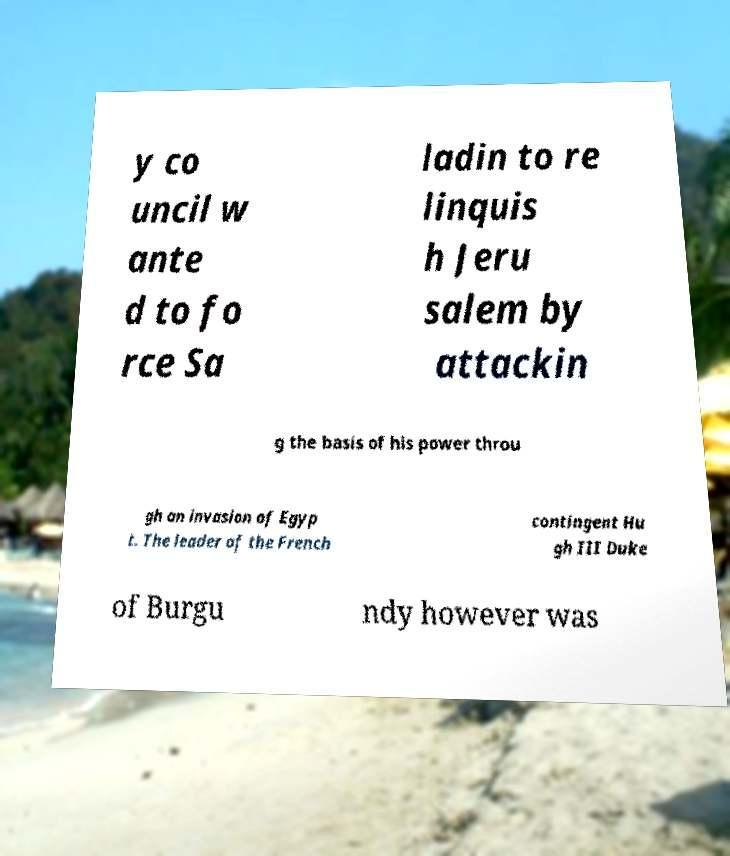Can you accurately transcribe the text from the provided image for me? y co uncil w ante d to fo rce Sa ladin to re linquis h Jeru salem by attackin g the basis of his power throu gh an invasion of Egyp t. The leader of the French contingent Hu gh III Duke of Burgu ndy however was 